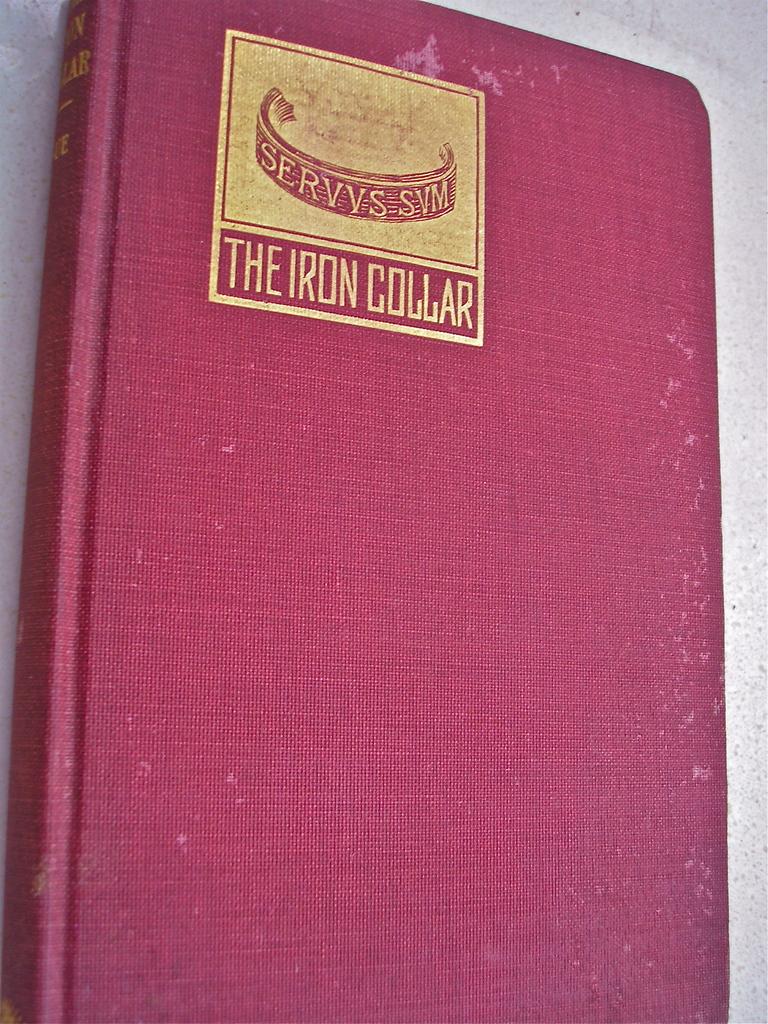What type of metal is the collar?
Ensure brevity in your answer.  Iron. What is the title of the book?
Your answer should be very brief. The iron collar. 